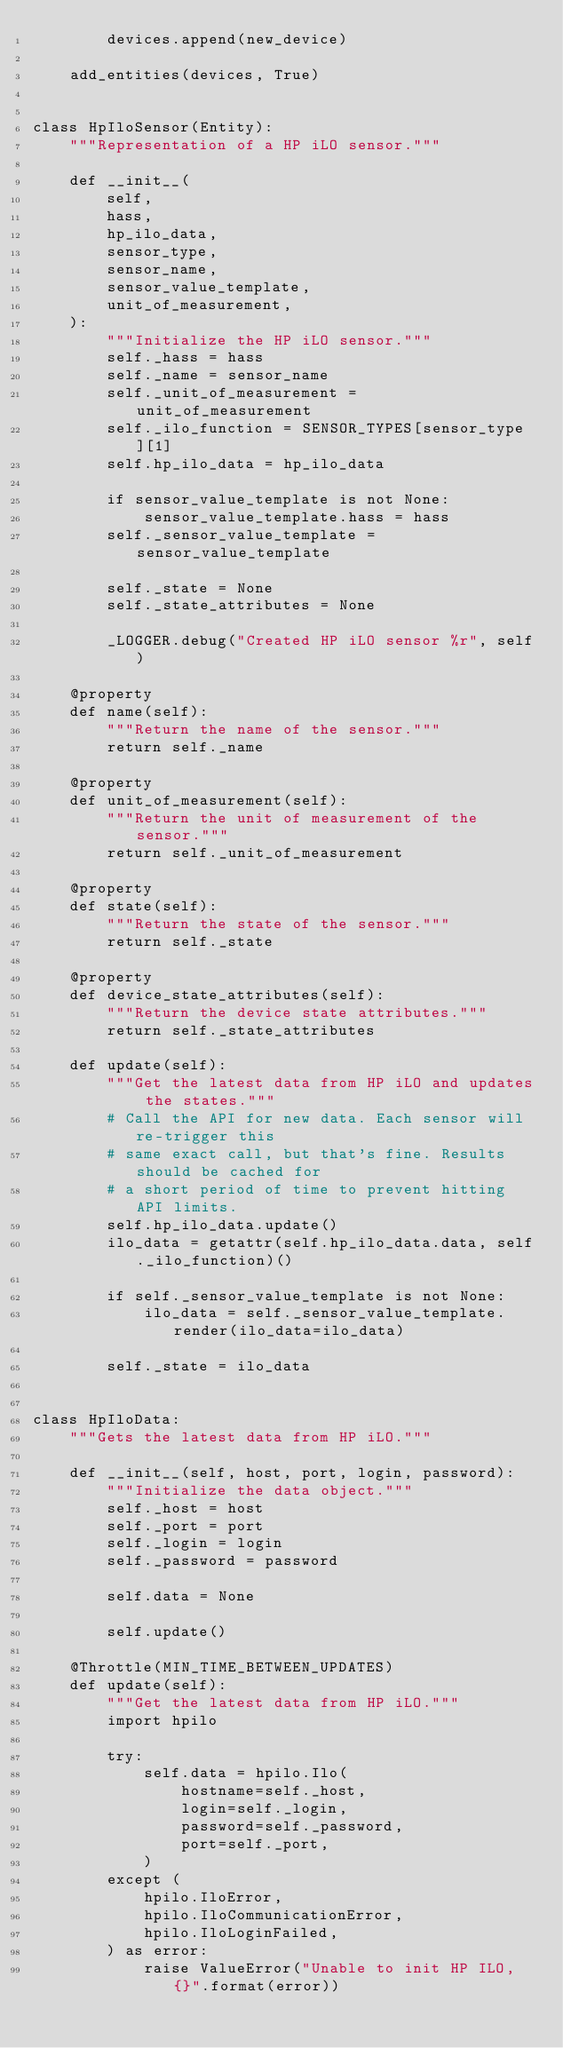<code> <loc_0><loc_0><loc_500><loc_500><_Python_>        devices.append(new_device)

    add_entities(devices, True)


class HpIloSensor(Entity):
    """Representation of a HP iLO sensor."""

    def __init__(
        self,
        hass,
        hp_ilo_data,
        sensor_type,
        sensor_name,
        sensor_value_template,
        unit_of_measurement,
    ):
        """Initialize the HP iLO sensor."""
        self._hass = hass
        self._name = sensor_name
        self._unit_of_measurement = unit_of_measurement
        self._ilo_function = SENSOR_TYPES[sensor_type][1]
        self.hp_ilo_data = hp_ilo_data

        if sensor_value_template is not None:
            sensor_value_template.hass = hass
        self._sensor_value_template = sensor_value_template

        self._state = None
        self._state_attributes = None

        _LOGGER.debug("Created HP iLO sensor %r", self)

    @property
    def name(self):
        """Return the name of the sensor."""
        return self._name

    @property
    def unit_of_measurement(self):
        """Return the unit of measurement of the sensor."""
        return self._unit_of_measurement

    @property
    def state(self):
        """Return the state of the sensor."""
        return self._state

    @property
    def device_state_attributes(self):
        """Return the device state attributes."""
        return self._state_attributes

    def update(self):
        """Get the latest data from HP iLO and updates the states."""
        # Call the API for new data. Each sensor will re-trigger this
        # same exact call, but that's fine. Results should be cached for
        # a short period of time to prevent hitting API limits.
        self.hp_ilo_data.update()
        ilo_data = getattr(self.hp_ilo_data.data, self._ilo_function)()

        if self._sensor_value_template is not None:
            ilo_data = self._sensor_value_template.render(ilo_data=ilo_data)

        self._state = ilo_data


class HpIloData:
    """Gets the latest data from HP iLO."""

    def __init__(self, host, port, login, password):
        """Initialize the data object."""
        self._host = host
        self._port = port
        self._login = login
        self._password = password

        self.data = None

        self.update()

    @Throttle(MIN_TIME_BETWEEN_UPDATES)
    def update(self):
        """Get the latest data from HP iLO."""
        import hpilo

        try:
            self.data = hpilo.Ilo(
                hostname=self._host,
                login=self._login,
                password=self._password,
                port=self._port,
            )
        except (
            hpilo.IloError,
            hpilo.IloCommunicationError,
            hpilo.IloLoginFailed,
        ) as error:
            raise ValueError("Unable to init HP ILO, {}".format(error))
</code> 